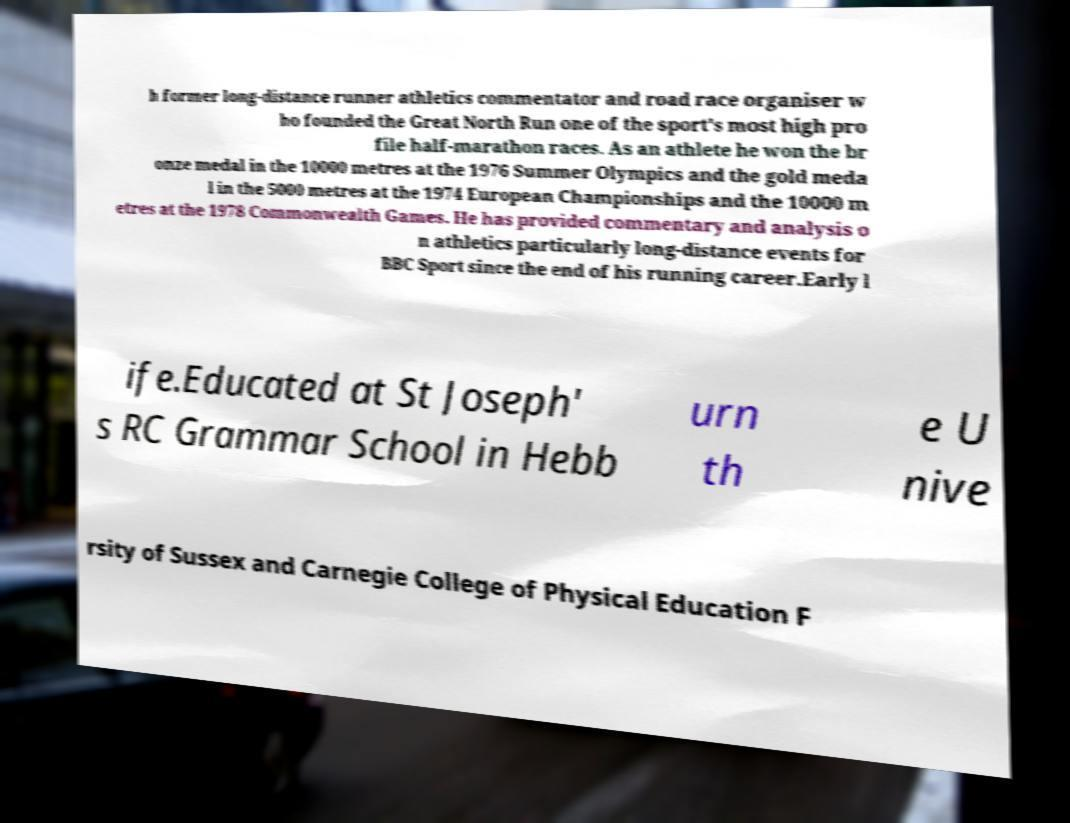What messages or text are displayed in this image? I need them in a readable, typed format. h former long-distance runner athletics commentator and road race organiser w ho founded the Great North Run one of the sport's most high pro file half-marathon races. As an athlete he won the br onze medal in the 10000 metres at the 1976 Summer Olympics and the gold meda l in the 5000 metres at the 1974 European Championships and the 10000 m etres at the 1978 Commonwealth Games. He has provided commentary and analysis o n athletics particularly long-distance events for BBC Sport since the end of his running career.Early l ife.Educated at St Joseph' s RC Grammar School in Hebb urn th e U nive rsity of Sussex and Carnegie College of Physical Education F 